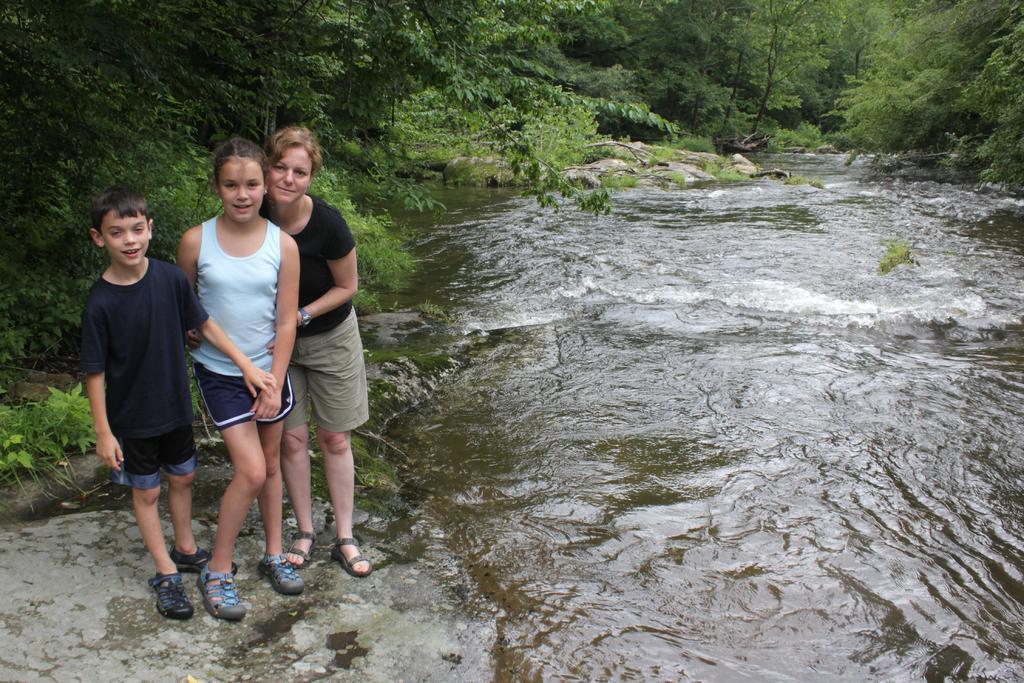Please provide a concise description of this image. Bottom left side of the image three persons standing and smiling. Behind them there are some trees. Bottom right side of the image there is water and there are some stones and trees. 